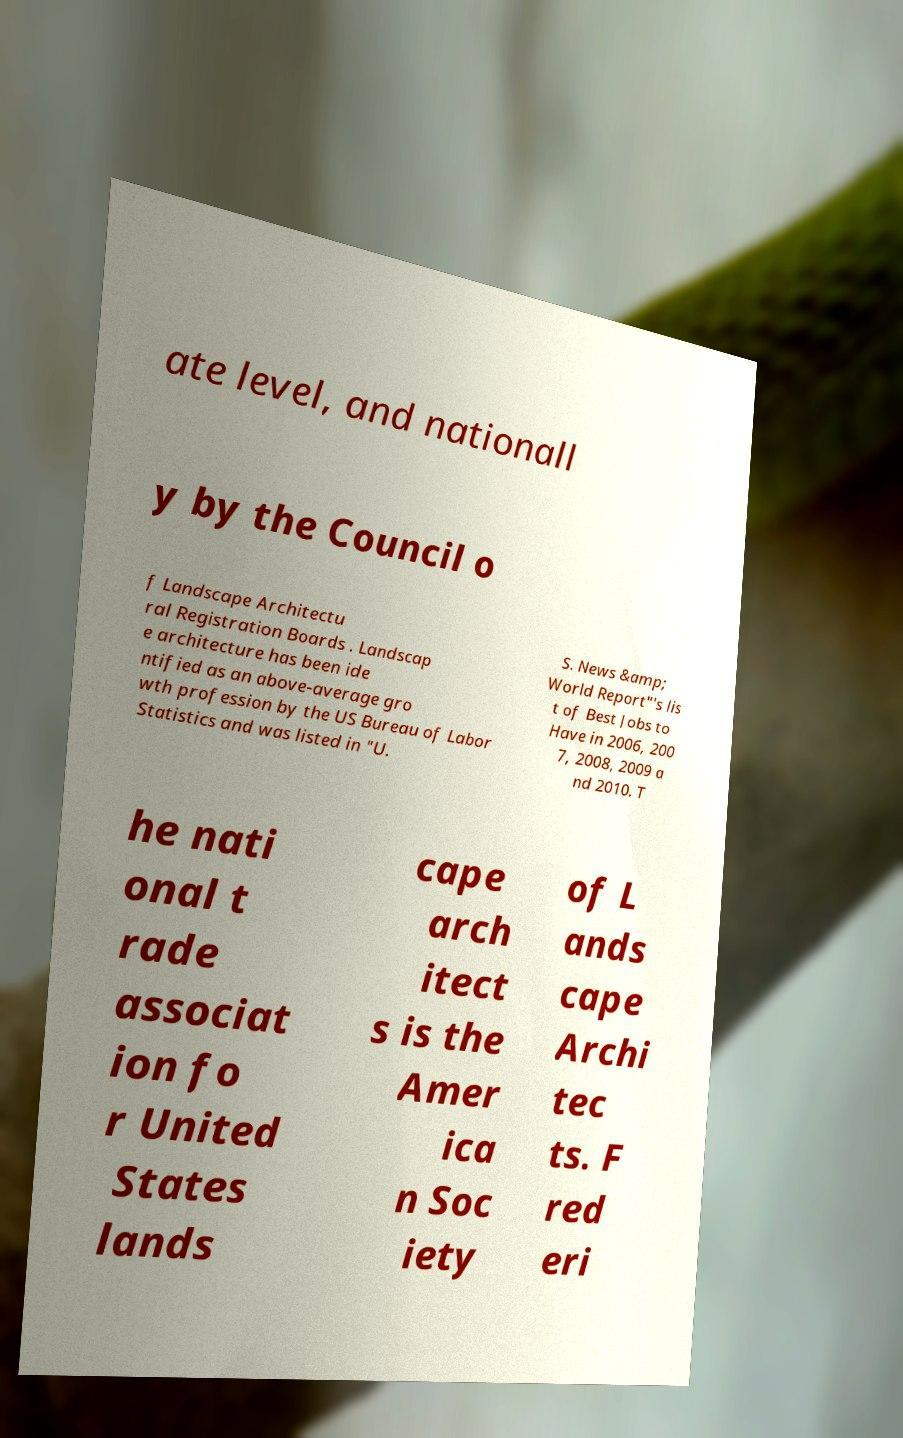Can you read and provide the text displayed in the image?This photo seems to have some interesting text. Can you extract and type it out for me? ate level, and nationall y by the Council o f Landscape Architectu ral Registration Boards . Landscap e architecture has been ide ntified as an above-average gro wth profession by the US Bureau of Labor Statistics and was listed in "U. S. News &amp; World Report"'s lis t of Best Jobs to Have in 2006, 200 7, 2008, 2009 a nd 2010. T he nati onal t rade associat ion fo r United States lands cape arch itect s is the Amer ica n Soc iety of L ands cape Archi tec ts. F red eri 